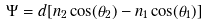Convert formula to latex. <formula><loc_0><loc_0><loc_500><loc_500>\Psi = d [ n _ { 2 } \cos ( \theta _ { 2 } ) - n _ { 1 } \cos ( \theta _ { 1 } ) ]</formula> 